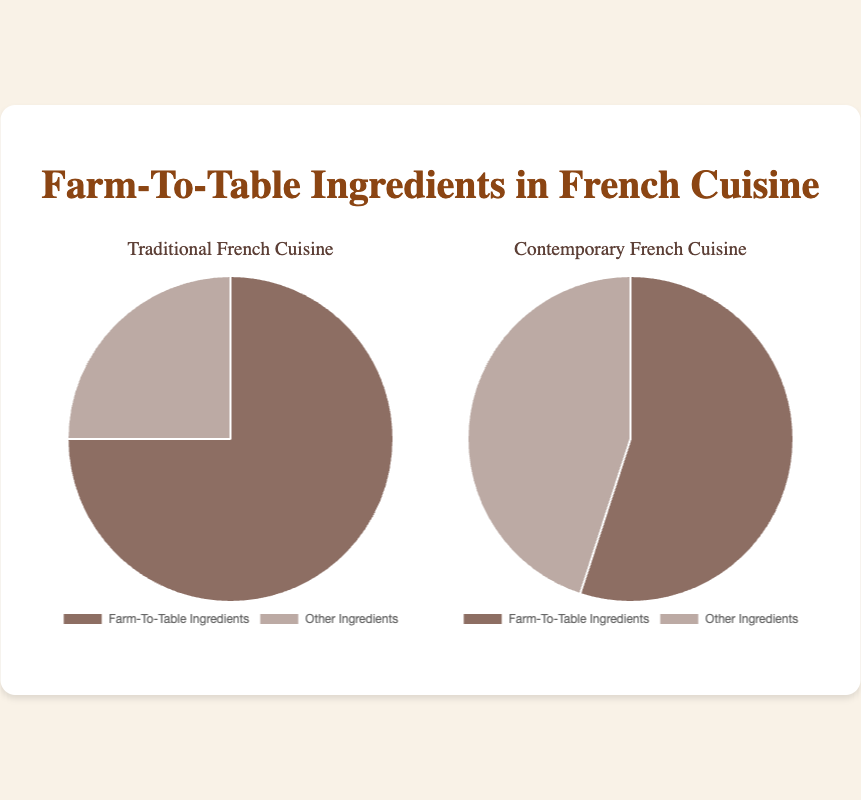What is the percentage of farm-to-table ingredients used in traditional French cuisine? The chart for Traditional French Cuisine shows two segments representing the percentages. The segment for farm-to-table ingredients is labeled as 75%.
Answer: 75% What percentage of ingredients in contemporary French cuisine are sourced other than farm-to-table? The chart for Contemporary French Cuisine includes a segment marked as 'Other Ingredients', which is labeled as 45%.
Answer: 45% How much higher is the percentage of farm-to-table ingredients in traditional French cuisine compared to contemporary French cuisine? The percentage of farm-to-table ingredients in traditional French cuisine is 75%, and in contemporary French cuisine, it is 55%. To find the difference: 75% - 55% = 20%.
Answer: 20% What is the combined percentage of other ingredients for both traditional and contemporary French cuisines? The percentage of other ingredients in traditional French cuisine is 25%, and in contemporary French cuisine, it is 45%. Combining these: 25% + 45% = 70%.
Answer: 70% Which type of cuisine utilizes a greater percentage of farm-to-table ingredients? Traditional French cuisine utilizes 75% farm-to-table ingredients, whereas contemporary French cuisine utilizes 55%, making traditional French cuisine the greater one.
Answer: Traditional French cuisine What is the visual representation color of farm-to-table ingredients in traditional French cuisine? The segment representing farm-to-table ingredients in the Traditional French Cuisine chart appears in a shade of brown. This can be identified as the broader segment in the pie chart.
Answer: Brownish What is the percentage difference in the use of other ingredients between traditional and contemporary French cuisine? The percentage of other ingredients in traditional French cuisine is 25%, and in contemporary French cuisine, it is 45%. The difference is calculated as: 45% - 25% = 20%.
Answer: 20% In which cuisine is the portion of 'other ingredients' visually larger? In the Contemporary French Cuisine chart, the segment for 'Other Ingredients' is larger than in the Traditional French Cuisine chart. This represents a 45% as opposed to 25%.
Answer: Contemporary French cuisine 